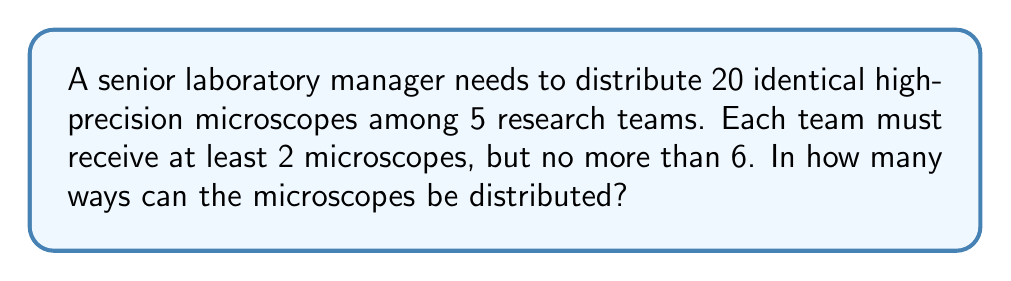Give your solution to this math problem. Let's approach this step-by-step:

1) This is a problem of distributing identical objects (microscopes) into distinct boxes (research teams) with restrictions. We can use the stars and bars method with modifications.

2) First, we need to ensure each team gets at least 2 microscopes. We can do this by giving 2 microscopes to each team at the start. This leaves us with:
   $20 - (5 \times 2) = 10$ microscopes to distribute

3) Now, we need to distribute these 10 microscopes among 5 teams, with each team getting no more than 4 additional microscopes (to stay within the 6 microscope limit).

4) This scenario can be represented as:
   $x_1 + x_2 + x_3 + x_4 + x_5 = 10$, where $0 \leq x_i \leq 4$ for all $i$

5) To solve this, we can use the generating function:
   $$(1 + z + z^2 + z^3 + z^4)^5$$

6) The coefficient of $z^{10}$ in this expansion will give us the number of ways to distribute the microscopes.

7) Expanding this using the binomial theorem would be complex, so we can use a computer algebra system or combinatorial reasoning to find the coefficient.

8) The result is 126.
Answer: 126 